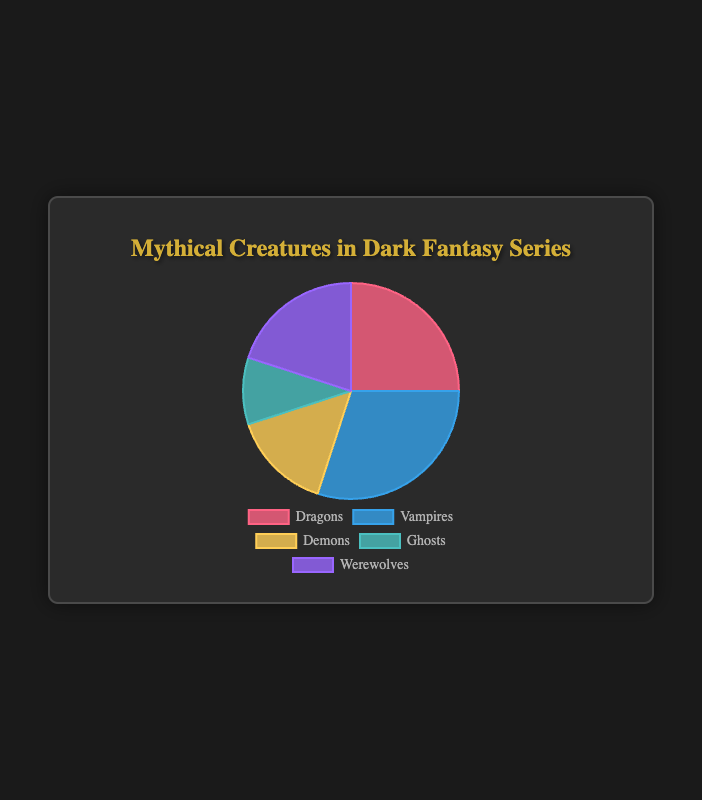What is the total percentage of Dragons and Vampires in the pie chart? The percentage of Dragons is 25% and the percentage of Vampires is 30%. Adding them together gives 25% + 30% = 55%.
Answer: 55% Which mythical creature has the lowest occurrence in the pie chart? From the pie chart, Ghosts have the lowest percentage at 10%.
Answer: Ghosts How many more Vampires are there compared to Demons in the pie chart? Vampires constitute 30% of the chart, while Demons constitute 15%. Subtracting these values gives 30% - 15% = 15%.
Answer: 15% Which creature holds the largest segment in the pie chart and what is its percentage? The Vampires segment is the largest, at 30%.
Answer: Vampires, 30% Describe the color associated with the Werewolves segment in the chart. The Werewolves segment is represented by a purple color.
Answer: purple What is the difference in percentage between the occurrences of Dragons and Ghosts? Dragons constitute 25% and Ghosts constitute 10%. Subtracting these gives 25% - 10% = 15%.
Answer: 15% Is the occurrence of Werewolves more than 15%? Yes, Werewolves have a percentage of 20%, which is greater than 15%.
Answer: Yes What fraction of the chart does Demons and Ghosts together represent? Demons are 15% and Ghosts are 10%. Adding them together gives 15% + 10% = 25%. As a fraction, this is 25/100 or 1/4.
Answer: 1/4 Between Dragons and Werewolves, which creature has a higher percentage and by how much? Dragons have a percentage of 25%, while Werewolves have 20%. The difference is 25% - 20% = 5%.
Answer: Dragons, 5% 